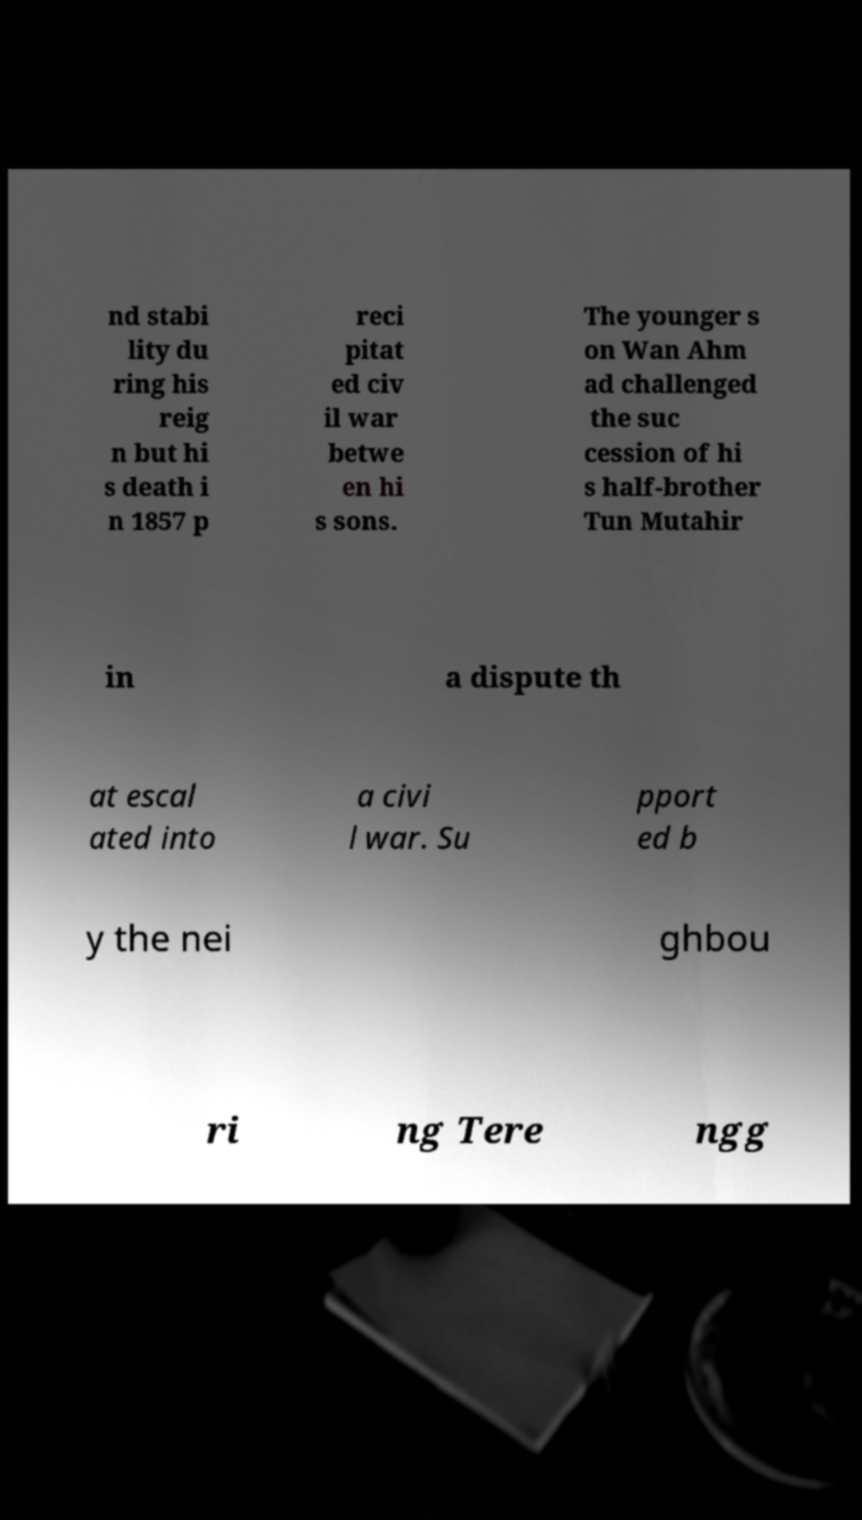Please identify and transcribe the text found in this image. nd stabi lity du ring his reig n but hi s death i n 1857 p reci pitat ed civ il war betwe en hi s sons. The younger s on Wan Ahm ad challenged the suc cession of hi s half-brother Tun Mutahir in a dispute th at escal ated into a civi l war. Su pport ed b y the nei ghbou ri ng Tere ngg 